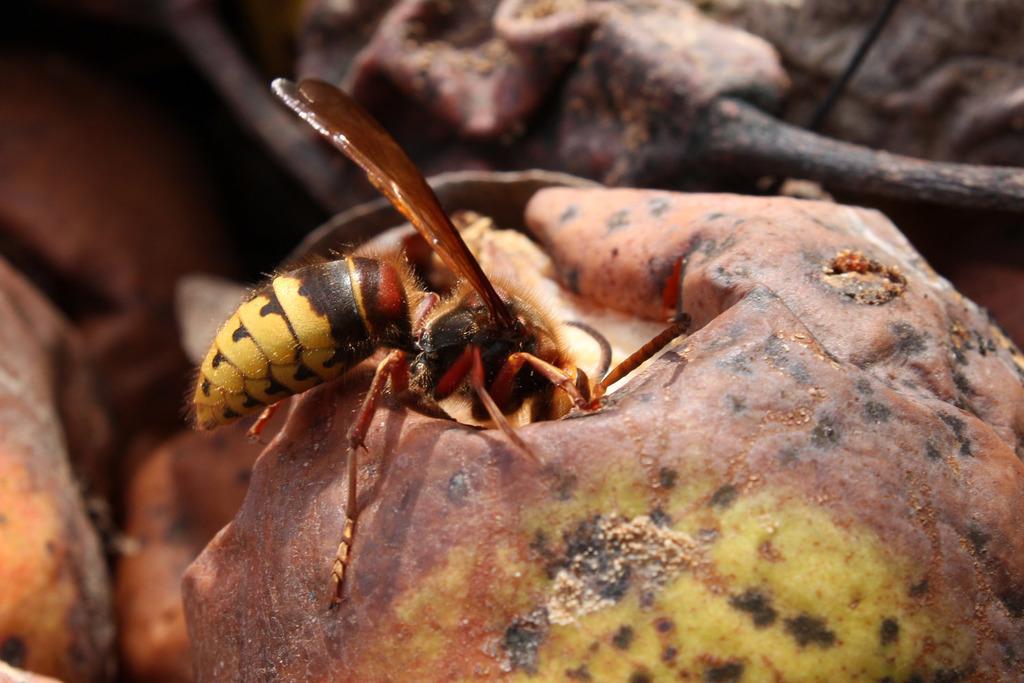In one or two sentences, can you explain what this image depicts? In this picture I can see an insect on the fruit, and there is blur background. 